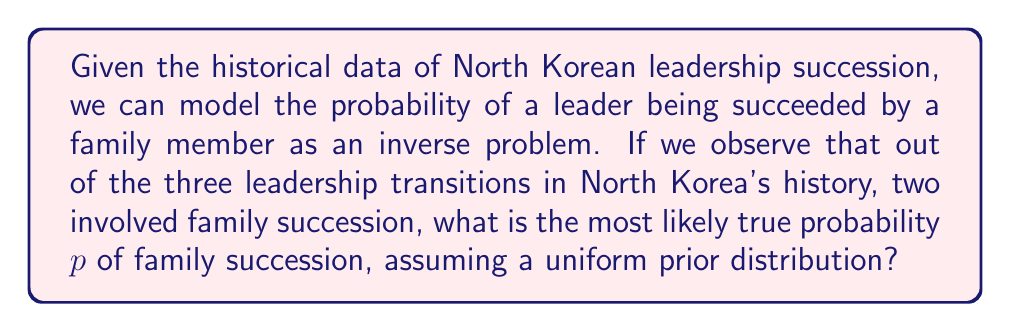Teach me how to tackle this problem. To solve this inverse problem, we'll use Bayesian inference:

1) Let $p$ be the true probability of family succession.

2) Our prior belief is a uniform distribution on $[0,1]$, i.e., $P(p) = 1$ for $0 \leq p \leq 1$.

3) The likelihood of observing 2 family successions out of 3 transitions, given $p$, is:

   $P(data|p) = \binom{3}{2}p^2(1-p)^1 = 3p^2(1-p)$

4) By Bayes' theorem:

   $P(p|data) \propto P(data|p)P(p) = 3p^2(1-p)$

5) To find the most likely $p$, we maximize this posterior probability:

   $\frac{d}{dp}[3p^2(1-p)] = 3(2p-3p^2) = 0$

6) Solving this equation:

   $2p-3p^2 = 0$
   $p(2-3p) = 0$
   $p = 0$ or $p = \frac{2}{3}$

7) The second derivative is negative at $p = \frac{2}{3}$, confirming it's a maximum.

Therefore, the most likely true probability of family succession is $\frac{2}{3}$.
Answer: $\frac{2}{3}$ 